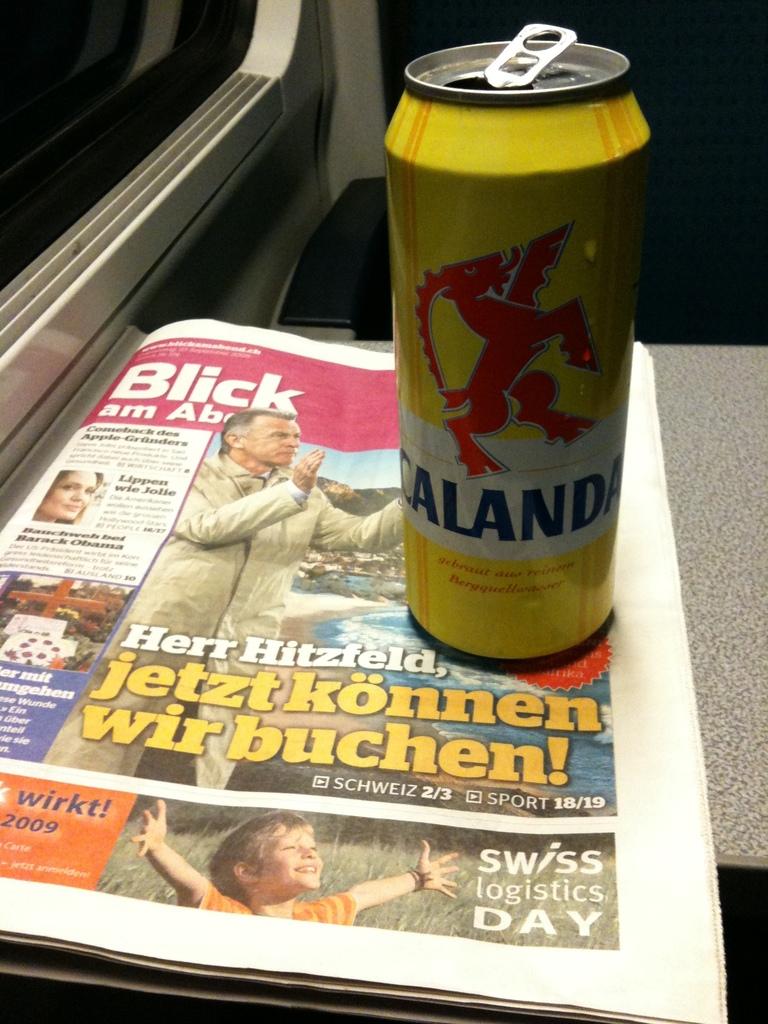What drink is this?
Make the answer very short. Calanda. What publication is this?
Your answer should be compact. Blick. 